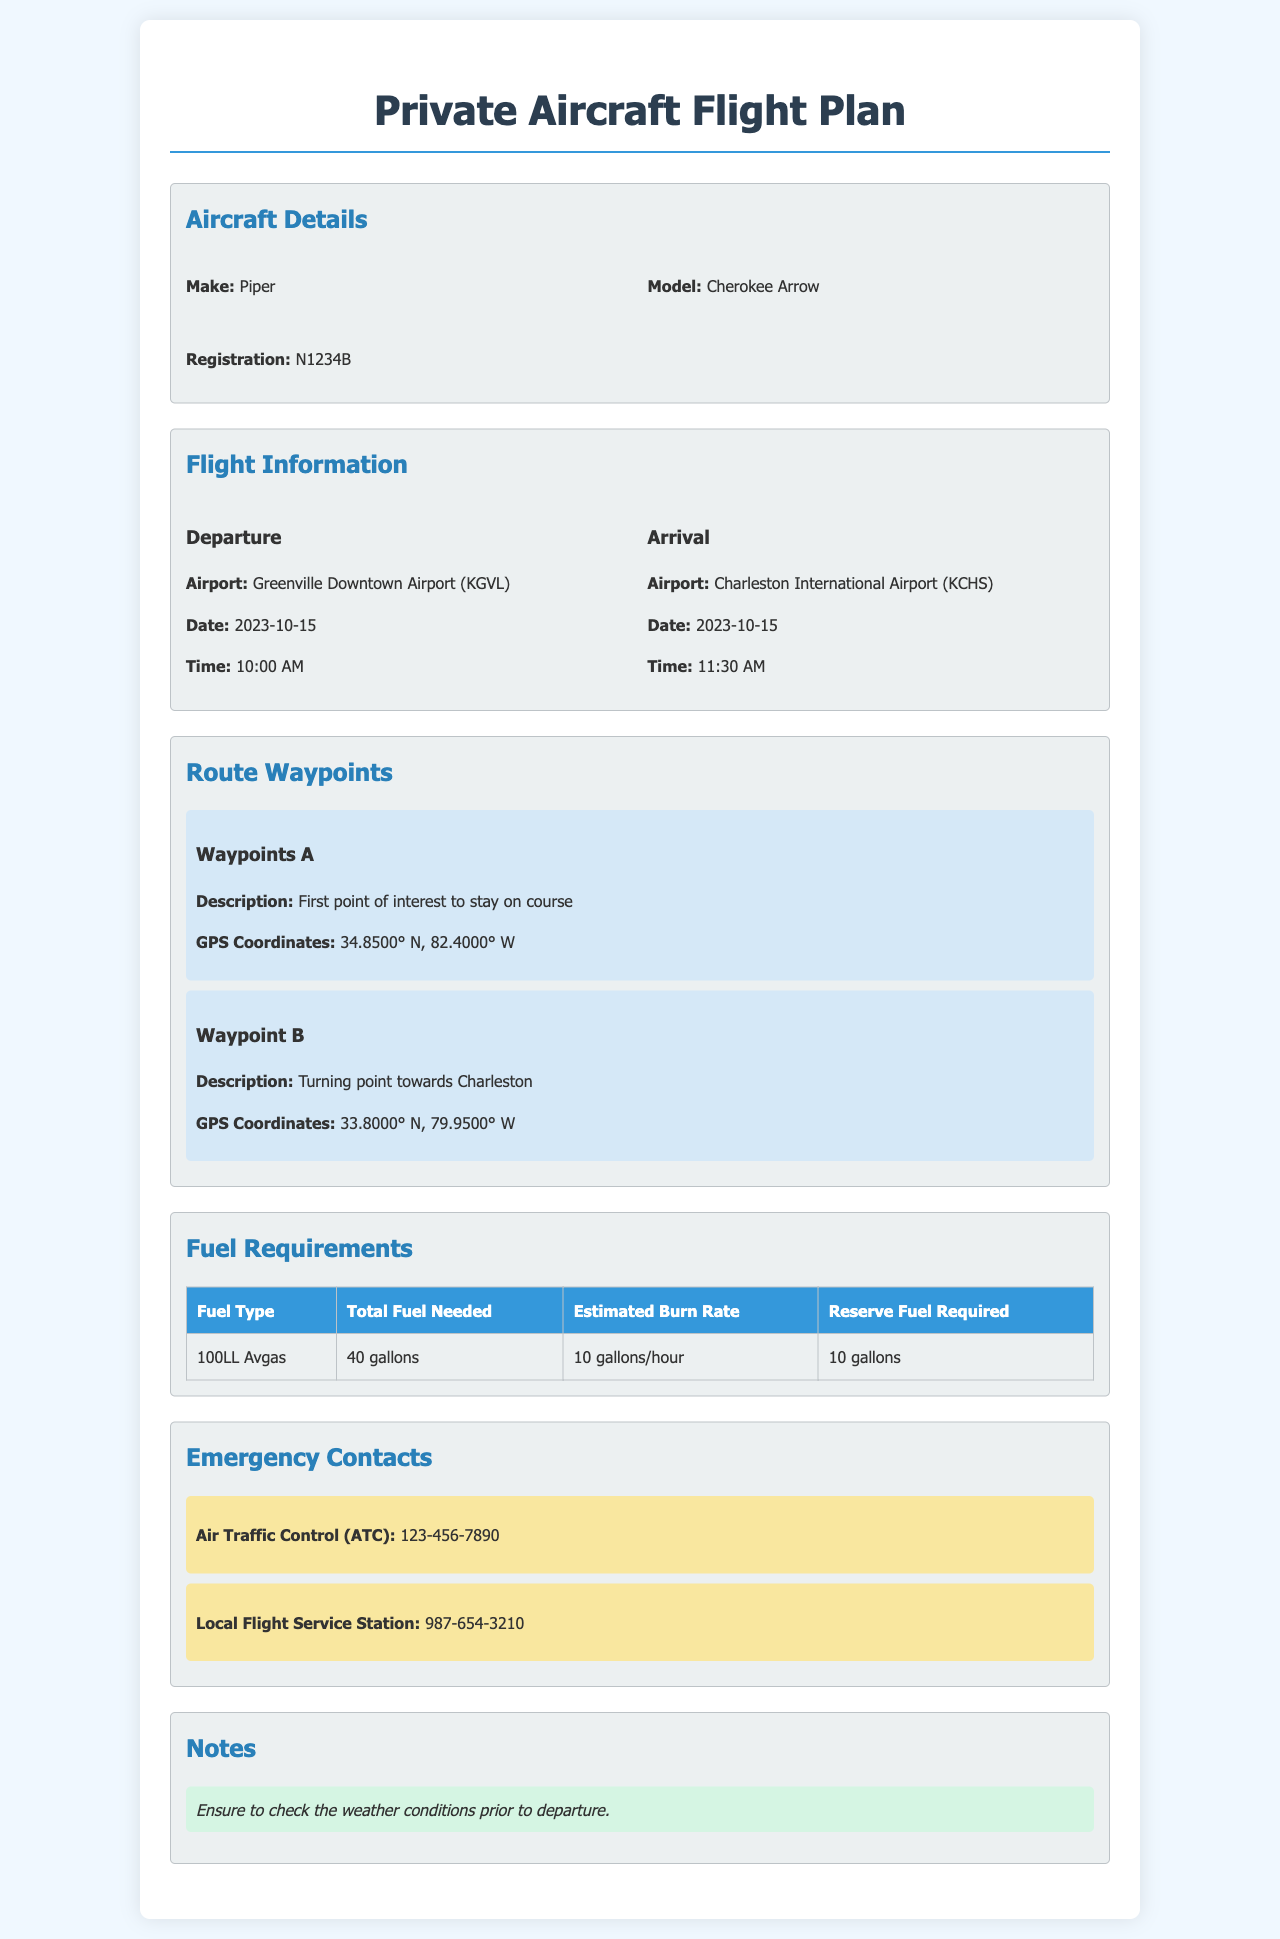What is the aircraft model? The model of the aircraft is specified under the Aircraft Details, which states "Cherokee Arrow."
Answer: Cherokee Arrow What is the departure airport? The departure airport is listed in the Flight Information section, specifically as "Greenville Downtown Airport (KGVL)."
Answer: Greenville Downtown Airport (KGVL) What time is the arrival scheduled for? The arrival time can be found in the Flight Information section, which states "11:30 AM."
Answer: 11:30 AM How many gallons of fuel are required in total? The total fuel needed is noted in the Fuel Requirements table, which indicates "40 gallons."
Answer: 40 gallons What is the estimated burn rate of fuel? The estimated burn rate is found in the Fuel Requirements section, defined as "10 gallons/hour."
Answer: 10 gallons/hour What are the GPS coordinates of Waypoint A? The GPS coordinates for Waypoint A are provided in the Route Waypoints section as "34.8500° N, 82.4000° W."
Answer: 34.8500° N, 82.4000° W What is the reserve fuel required? The reserve fuel required is stated in the Fuel Requirements table as "10 gallons."
Answer: 10 gallons Who is the Air Traffic Control contact? The Air Traffic Control contact number is found in the Emergency Contacts section, which is listed as "123-456-7890."
Answer: 123-456-7890 What date is the flight scheduled for? The date of the flight is indicated in both the Departure and Arrival sections as "2023-10-15."
Answer: 2023-10-15 